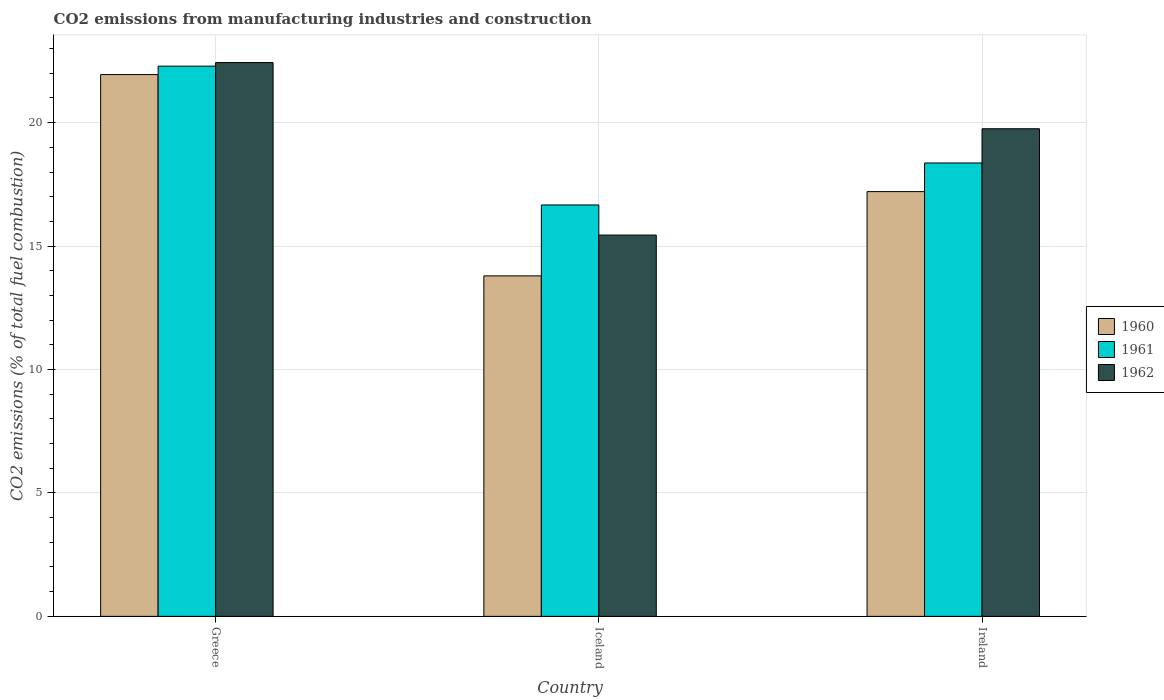Are the number of bars per tick equal to the number of legend labels?
Make the answer very short. Yes. How many bars are there on the 1st tick from the right?
Give a very brief answer. 3. What is the label of the 1st group of bars from the left?
Offer a terse response. Greece. What is the amount of CO2 emitted in 1961 in Iceland?
Offer a very short reply. 16.67. Across all countries, what is the maximum amount of CO2 emitted in 1960?
Ensure brevity in your answer.  21.95. Across all countries, what is the minimum amount of CO2 emitted in 1960?
Your response must be concise. 13.79. In which country was the amount of CO2 emitted in 1960 maximum?
Offer a very short reply. Greece. In which country was the amount of CO2 emitted in 1962 minimum?
Keep it short and to the point. Iceland. What is the total amount of CO2 emitted in 1960 in the graph?
Your answer should be very brief. 52.95. What is the difference between the amount of CO2 emitted in 1961 in Greece and that in Ireland?
Your answer should be compact. 3.92. What is the difference between the amount of CO2 emitted in 1962 in Greece and the amount of CO2 emitted in 1960 in Iceland?
Ensure brevity in your answer.  8.64. What is the average amount of CO2 emitted in 1960 per country?
Your answer should be compact. 17.65. What is the difference between the amount of CO2 emitted of/in 1960 and amount of CO2 emitted of/in 1961 in Greece?
Your answer should be compact. -0.34. What is the ratio of the amount of CO2 emitted in 1960 in Greece to that in Ireland?
Ensure brevity in your answer.  1.28. Is the amount of CO2 emitted in 1960 in Greece less than that in Iceland?
Give a very brief answer. No. Is the difference between the amount of CO2 emitted in 1960 in Greece and Ireland greater than the difference between the amount of CO2 emitted in 1961 in Greece and Ireland?
Provide a short and direct response. Yes. What is the difference between the highest and the second highest amount of CO2 emitted in 1962?
Keep it short and to the point. -2.68. What is the difference between the highest and the lowest amount of CO2 emitted in 1961?
Ensure brevity in your answer.  5.62. In how many countries, is the amount of CO2 emitted in 1961 greater than the average amount of CO2 emitted in 1961 taken over all countries?
Ensure brevity in your answer.  1. Is the sum of the amount of CO2 emitted in 1961 in Greece and Ireland greater than the maximum amount of CO2 emitted in 1960 across all countries?
Offer a very short reply. Yes. What does the 2nd bar from the left in Iceland represents?
Make the answer very short. 1961. What does the 1st bar from the right in Greece represents?
Offer a terse response. 1962. Is it the case that in every country, the sum of the amount of CO2 emitted in 1960 and amount of CO2 emitted in 1962 is greater than the amount of CO2 emitted in 1961?
Give a very brief answer. Yes. How many bars are there?
Your answer should be very brief. 9. Are all the bars in the graph horizontal?
Make the answer very short. No. Does the graph contain any zero values?
Offer a very short reply. No. Does the graph contain grids?
Provide a succinct answer. Yes. How many legend labels are there?
Offer a terse response. 3. How are the legend labels stacked?
Provide a succinct answer. Vertical. What is the title of the graph?
Offer a terse response. CO2 emissions from manufacturing industries and construction. What is the label or title of the Y-axis?
Your answer should be compact. CO2 emissions (% of total fuel combustion). What is the CO2 emissions (% of total fuel combustion) of 1960 in Greece?
Give a very brief answer. 21.95. What is the CO2 emissions (% of total fuel combustion) in 1961 in Greece?
Offer a very short reply. 22.29. What is the CO2 emissions (% of total fuel combustion) in 1962 in Greece?
Your response must be concise. 22.44. What is the CO2 emissions (% of total fuel combustion) of 1960 in Iceland?
Ensure brevity in your answer.  13.79. What is the CO2 emissions (% of total fuel combustion) of 1961 in Iceland?
Provide a succinct answer. 16.67. What is the CO2 emissions (% of total fuel combustion) in 1962 in Iceland?
Your answer should be compact. 15.45. What is the CO2 emissions (% of total fuel combustion) in 1960 in Ireland?
Your answer should be very brief. 17.21. What is the CO2 emissions (% of total fuel combustion) of 1961 in Ireland?
Offer a terse response. 18.37. What is the CO2 emissions (% of total fuel combustion) of 1962 in Ireland?
Provide a succinct answer. 19.75. Across all countries, what is the maximum CO2 emissions (% of total fuel combustion) of 1960?
Offer a terse response. 21.95. Across all countries, what is the maximum CO2 emissions (% of total fuel combustion) in 1961?
Give a very brief answer. 22.29. Across all countries, what is the maximum CO2 emissions (% of total fuel combustion) in 1962?
Your answer should be very brief. 22.44. Across all countries, what is the minimum CO2 emissions (% of total fuel combustion) of 1960?
Make the answer very short. 13.79. Across all countries, what is the minimum CO2 emissions (% of total fuel combustion) in 1961?
Your response must be concise. 16.67. Across all countries, what is the minimum CO2 emissions (% of total fuel combustion) of 1962?
Ensure brevity in your answer.  15.45. What is the total CO2 emissions (% of total fuel combustion) in 1960 in the graph?
Provide a succinct answer. 52.95. What is the total CO2 emissions (% of total fuel combustion) of 1961 in the graph?
Offer a very short reply. 57.32. What is the total CO2 emissions (% of total fuel combustion) of 1962 in the graph?
Provide a short and direct response. 57.64. What is the difference between the CO2 emissions (% of total fuel combustion) in 1960 in Greece and that in Iceland?
Make the answer very short. 8.15. What is the difference between the CO2 emissions (% of total fuel combustion) of 1961 in Greece and that in Iceland?
Give a very brief answer. 5.62. What is the difference between the CO2 emissions (% of total fuel combustion) in 1962 in Greece and that in Iceland?
Provide a succinct answer. 6.99. What is the difference between the CO2 emissions (% of total fuel combustion) in 1960 in Greece and that in Ireland?
Offer a very short reply. 4.74. What is the difference between the CO2 emissions (% of total fuel combustion) in 1961 in Greece and that in Ireland?
Provide a short and direct response. 3.92. What is the difference between the CO2 emissions (% of total fuel combustion) of 1962 in Greece and that in Ireland?
Ensure brevity in your answer.  2.68. What is the difference between the CO2 emissions (% of total fuel combustion) in 1960 in Iceland and that in Ireland?
Provide a short and direct response. -3.41. What is the difference between the CO2 emissions (% of total fuel combustion) of 1961 in Iceland and that in Ireland?
Ensure brevity in your answer.  -1.7. What is the difference between the CO2 emissions (% of total fuel combustion) in 1962 in Iceland and that in Ireland?
Your response must be concise. -4.31. What is the difference between the CO2 emissions (% of total fuel combustion) of 1960 in Greece and the CO2 emissions (% of total fuel combustion) of 1961 in Iceland?
Keep it short and to the point. 5.28. What is the difference between the CO2 emissions (% of total fuel combustion) in 1960 in Greece and the CO2 emissions (% of total fuel combustion) in 1962 in Iceland?
Keep it short and to the point. 6.5. What is the difference between the CO2 emissions (% of total fuel combustion) of 1961 in Greece and the CO2 emissions (% of total fuel combustion) of 1962 in Iceland?
Your answer should be very brief. 6.84. What is the difference between the CO2 emissions (% of total fuel combustion) of 1960 in Greece and the CO2 emissions (% of total fuel combustion) of 1961 in Ireland?
Provide a short and direct response. 3.58. What is the difference between the CO2 emissions (% of total fuel combustion) of 1960 in Greece and the CO2 emissions (% of total fuel combustion) of 1962 in Ireland?
Offer a very short reply. 2.19. What is the difference between the CO2 emissions (% of total fuel combustion) in 1961 in Greece and the CO2 emissions (% of total fuel combustion) in 1962 in Ireland?
Offer a very short reply. 2.54. What is the difference between the CO2 emissions (% of total fuel combustion) in 1960 in Iceland and the CO2 emissions (% of total fuel combustion) in 1961 in Ireland?
Offer a terse response. -4.57. What is the difference between the CO2 emissions (% of total fuel combustion) in 1960 in Iceland and the CO2 emissions (% of total fuel combustion) in 1962 in Ireland?
Provide a succinct answer. -5.96. What is the difference between the CO2 emissions (% of total fuel combustion) in 1961 in Iceland and the CO2 emissions (% of total fuel combustion) in 1962 in Ireland?
Your response must be concise. -3.09. What is the average CO2 emissions (% of total fuel combustion) in 1960 per country?
Ensure brevity in your answer.  17.65. What is the average CO2 emissions (% of total fuel combustion) of 1961 per country?
Your response must be concise. 19.11. What is the average CO2 emissions (% of total fuel combustion) in 1962 per country?
Offer a very short reply. 19.21. What is the difference between the CO2 emissions (% of total fuel combustion) in 1960 and CO2 emissions (% of total fuel combustion) in 1961 in Greece?
Keep it short and to the point. -0.34. What is the difference between the CO2 emissions (% of total fuel combustion) in 1960 and CO2 emissions (% of total fuel combustion) in 1962 in Greece?
Your answer should be very brief. -0.49. What is the difference between the CO2 emissions (% of total fuel combustion) of 1961 and CO2 emissions (% of total fuel combustion) of 1962 in Greece?
Give a very brief answer. -0.15. What is the difference between the CO2 emissions (% of total fuel combustion) of 1960 and CO2 emissions (% of total fuel combustion) of 1961 in Iceland?
Provide a short and direct response. -2.87. What is the difference between the CO2 emissions (% of total fuel combustion) of 1960 and CO2 emissions (% of total fuel combustion) of 1962 in Iceland?
Give a very brief answer. -1.65. What is the difference between the CO2 emissions (% of total fuel combustion) of 1961 and CO2 emissions (% of total fuel combustion) of 1962 in Iceland?
Your answer should be compact. 1.22. What is the difference between the CO2 emissions (% of total fuel combustion) in 1960 and CO2 emissions (% of total fuel combustion) in 1961 in Ireland?
Offer a very short reply. -1.16. What is the difference between the CO2 emissions (% of total fuel combustion) in 1960 and CO2 emissions (% of total fuel combustion) in 1962 in Ireland?
Your answer should be compact. -2.55. What is the difference between the CO2 emissions (% of total fuel combustion) in 1961 and CO2 emissions (% of total fuel combustion) in 1962 in Ireland?
Provide a short and direct response. -1.39. What is the ratio of the CO2 emissions (% of total fuel combustion) of 1960 in Greece to that in Iceland?
Your answer should be very brief. 1.59. What is the ratio of the CO2 emissions (% of total fuel combustion) of 1961 in Greece to that in Iceland?
Provide a short and direct response. 1.34. What is the ratio of the CO2 emissions (% of total fuel combustion) in 1962 in Greece to that in Iceland?
Give a very brief answer. 1.45. What is the ratio of the CO2 emissions (% of total fuel combustion) in 1960 in Greece to that in Ireland?
Offer a very short reply. 1.28. What is the ratio of the CO2 emissions (% of total fuel combustion) of 1961 in Greece to that in Ireland?
Ensure brevity in your answer.  1.21. What is the ratio of the CO2 emissions (% of total fuel combustion) in 1962 in Greece to that in Ireland?
Make the answer very short. 1.14. What is the ratio of the CO2 emissions (% of total fuel combustion) of 1960 in Iceland to that in Ireland?
Offer a very short reply. 0.8. What is the ratio of the CO2 emissions (% of total fuel combustion) in 1961 in Iceland to that in Ireland?
Give a very brief answer. 0.91. What is the ratio of the CO2 emissions (% of total fuel combustion) in 1962 in Iceland to that in Ireland?
Provide a succinct answer. 0.78. What is the difference between the highest and the second highest CO2 emissions (% of total fuel combustion) in 1960?
Your answer should be compact. 4.74. What is the difference between the highest and the second highest CO2 emissions (% of total fuel combustion) in 1961?
Offer a very short reply. 3.92. What is the difference between the highest and the second highest CO2 emissions (% of total fuel combustion) in 1962?
Make the answer very short. 2.68. What is the difference between the highest and the lowest CO2 emissions (% of total fuel combustion) of 1960?
Provide a short and direct response. 8.15. What is the difference between the highest and the lowest CO2 emissions (% of total fuel combustion) in 1961?
Keep it short and to the point. 5.62. What is the difference between the highest and the lowest CO2 emissions (% of total fuel combustion) of 1962?
Keep it short and to the point. 6.99. 